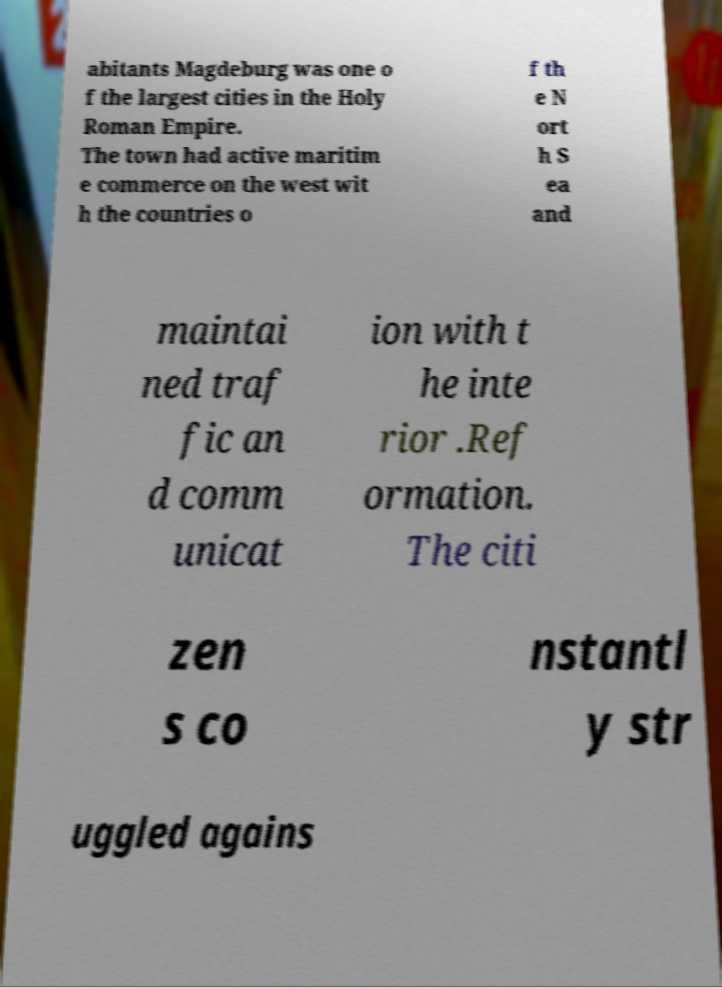There's text embedded in this image that I need extracted. Can you transcribe it verbatim? abitants Magdeburg was one o f the largest cities in the Holy Roman Empire. The town had active maritim e commerce on the west wit h the countries o f th e N ort h S ea and maintai ned traf fic an d comm unicat ion with t he inte rior .Ref ormation. The citi zen s co nstantl y str uggled agains 